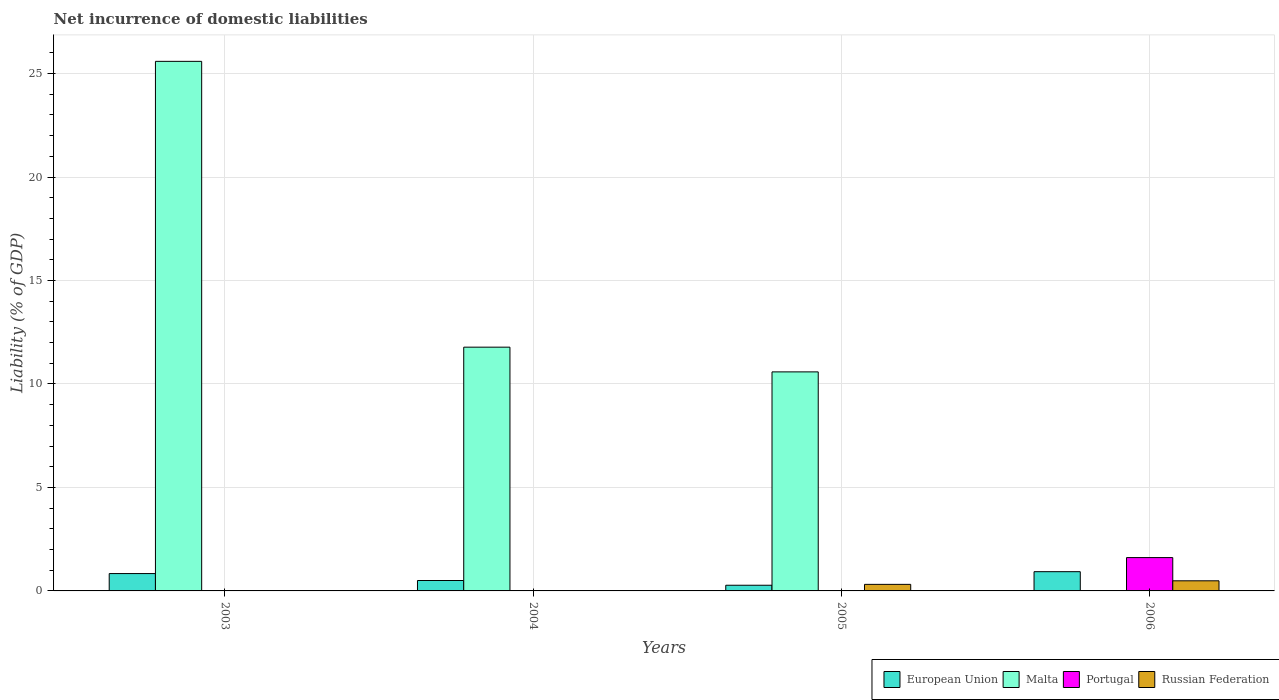How many groups of bars are there?
Offer a very short reply. 4. Are the number of bars on each tick of the X-axis equal?
Your answer should be very brief. No. How many bars are there on the 1st tick from the left?
Offer a terse response. 3. How many bars are there on the 3rd tick from the right?
Offer a very short reply. 2. In how many cases, is the number of bars for a given year not equal to the number of legend labels?
Your response must be concise. 4. What is the net incurrence of domestic liabilities in Portugal in 2003?
Your answer should be very brief. 0.01. Across all years, what is the maximum net incurrence of domestic liabilities in Malta?
Provide a short and direct response. 25.59. What is the total net incurrence of domestic liabilities in Portugal in the graph?
Ensure brevity in your answer.  1.62. What is the difference between the net incurrence of domestic liabilities in European Union in 2004 and that in 2006?
Provide a succinct answer. -0.43. What is the difference between the net incurrence of domestic liabilities in Portugal in 2003 and the net incurrence of domestic liabilities in European Union in 2004?
Your response must be concise. -0.49. What is the average net incurrence of domestic liabilities in European Union per year?
Provide a short and direct response. 0.64. In the year 2003, what is the difference between the net incurrence of domestic liabilities in Malta and net incurrence of domestic liabilities in Portugal?
Provide a succinct answer. 25.58. In how many years, is the net incurrence of domestic liabilities in Portugal greater than 5 %?
Make the answer very short. 0. What is the ratio of the net incurrence of domestic liabilities in European Union in 2003 to that in 2004?
Your answer should be compact. 1.67. What is the difference between the highest and the second highest net incurrence of domestic liabilities in Malta?
Give a very brief answer. 13.81. What is the difference between the highest and the lowest net incurrence of domestic liabilities in Russian Federation?
Ensure brevity in your answer.  0.49. Is the sum of the net incurrence of domestic liabilities in European Union in 2005 and 2006 greater than the maximum net incurrence of domestic liabilities in Russian Federation across all years?
Keep it short and to the point. Yes. Is it the case that in every year, the sum of the net incurrence of domestic liabilities in Portugal and net incurrence of domestic liabilities in Malta is greater than the sum of net incurrence of domestic liabilities in European Union and net incurrence of domestic liabilities in Russian Federation?
Your answer should be very brief. Yes. Is it the case that in every year, the sum of the net incurrence of domestic liabilities in Portugal and net incurrence of domestic liabilities in Russian Federation is greater than the net incurrence of domestic liabilities in Malta?
Offer a terse response. No. Are all the bars in the graph horizontal?
Give a very brief answer. No. What is the difference between two consecutive major ticks on the Y-axis?
Provide a short and direct response. 5. Are the values on the major ticks of Y-axis written in scientific E-notation?
Keep it short and to the point. No. Does the graph contain any zero values?
Offer a very short reply. Yes. How are the legend labels stacked?
Provide a short and direct response. Horizontal. What is the title of the graph?
Make the answer very short. Net incurrence of domestic liabilities. Does "Niger" appear as one of the legend labels in the graph?
Ensure brevity in your answer.  No. What is the label or title of the Y-axis?
Offer a very short reply. Liability (% of GDP). What is the Liability (% of GDP) in European Union in 2003?
Give a very brief answer. 0.84. What is the Liability (% of GDP) in Malta in 2003?
Offer a terse response. 25.59. What is the Liability (% of GDP) in Portugal in 2003?
Keep it short and to the point. 0.01. What is the Liability (% of GDP) of Russian Federation in 2003?
Your answer should be compact. 0. What is the Liability (% of GDP) of European Union in 2004?
Provide a short and direct response. 0.5. What is the Liability (% of GDP) of Malta in 2004?
Offer a very short reply. 11.78. What is the Liability (% of GDP) in European Union in 2005?
Your response must be concise. 0.27. What is the Liability (% of GDP) of Malta in 2005?
Your response must be concise. 10.58. What is the Liability (% of GDP) in Portugal in 2005?
Offer a terse response. 0. What is the Liability (% of GDP) of Russian Federation in 2005?
Offer a terse response. 0.32. What is the Liability (% of GDP) in European Union in 2006?
Offer a terse response. 0.93. What is the Liability (% of GDP) of Portugal in 2006?
Offer a very short reply. 1.61. What is the Liability (% of GDP) in Russian Federation in 2006?
Your answer should be compact. 0.49. Across all years, what is the maximum Liability (% of GDP) of European Union?
Give a very brief answer. 0.93. Across all years, what is the maximum Liability (% of GDP) in Malta?
Your response must be concise. 25.59. Across all years, what is the maximum Liability (% of GDP) of Portugal?
Make the answer very short. 1.61. Across all years, what is the maximum Liability (% of GDP) in Russian Federation?
Keep it short and to the point. 0.49. Across all years, what is the minimum Liability (% of GDP) of European Union?
Provide a succinct answer. 0.27. What is the total Liability (% of GDP) of European Union in the graph?
Your answer should be compact. 2.55. What is the total Liability (% of GDP) of Malta in the graph?
Your response must be concise. 47.95. What is the total Liability (% of GDP) in Portugal in the graph?
Ensure brevity in your answer.  1.62. What is the total Liability (% of GDP) in Russian Federation in the graph?
Offer a terse response. 0.81. What is the difference between the Liability (% of GDP) of European Union in 2003 and that in 2004?
Ensure brevity in your answer.  0.34. What is the difference between the Liability (% of GDP) of Malta in 2003 and that in 2004?
Ensure brevity in your answer.  13.81. What is the difference between the Liability (% of GDP) in European Union in 2003 and that in 2005?
Provide a succinct answer. 0.56. What is the difference between the Liability (% of GDP) of Malta in 2003 and that in 2005?
Provide a succinct answer. 15.01. What is the difference between the Liability (% of GDP) of European Union in 2003 and that in 2006?
Provide a succinct answer. -0.09. What is the difference between the Liability (% of GDP) in Portugal in 2003 and that in 2006?
Provide a short and direct response. -1.6. What is the difference between the Liability (% of GDP) in European Union in 2004 and that in 2005?
Keep it short and to the point. 0.23. What is the difference between the Liability (% of GDP) of Malta in 2004 and that in 2005?
Keep it short and to the point. 1.19. What is the difference between the Liability (% of GDP) in European Union in 2004 and that in 2006?
Provide a succinct answer. -0.43. What is the difference between the Liability (% of GDP) of European Union in 2005 and that in 2006?
Your response must be concise. -0.66. What is the difference between the Liability (% of GDP) in Russian Federation in 2005 and that in 2006?
Your answer should be compact. -0.17. What is the difference between the Liability (% of GDP) in European Union in 2003 and the Liability (% of GDP) in Malta in 2004?
Provide a short and direct response. -10.94. What is the difference between the Liability (% of GDP) of European Union in 2003 and the Liability (% of GDP) of Malta in 2005?
Offer a very short reply. -9.75. What is the difference between the Liability (% of GDP) in European Union in 2003 and the Liability (% of GDP) in Russian Federation in 2005?
Your answer should be very brief. 0.52. What is the difference between the Liability (% of GDP) of Malta in 2003 and the Liability (% of GDP) of Russian Federation in 2005?
Provide a succinct answer. 25.27. What is the difference between the Liability (% of GDP) in Portugal in 2003 and the Liability (% of GDP) in Russian Federation in 2005?
Your answer should be compact. -0.31. What is the difference between the Liability (% of GDP) of European Union in 2003 and the Liability (% of GDP) of Portugal in 2006?
Make the answer very short. -0.77. What is the difference between the Liability (% of GDP) in European Union in 2003 and the Liability (% of GDP) in Russian Federation in 2006?
Give a very brief answer. 0.35. What is the difference between the Liability (% of GDP) of Malta in 2003 and the Liability (% of GDP) of Portugal in 2006?
Provide a short and direct response. 23.98. What is the difference between the Liability (% of GDP) of Malta in 2003 and the Liability (% of GDP) of Russian Federation in 2006?
Your response must be concise. 25.1. What is the difference between the Liability (% of GDP) of Portugal in 2003 and the Liability (% of GDP) of Russian Federation in 2006?
Give a very brief answer. -0.48. What is the difference between the Liability (% of GDP) of European Union in 2004 and the Liability (% of GDP) of Malta in 2005?
Provide a succinct answer. -10.08. What is the difference between the Liability (% of GDP) in European Union in 2004 and the Liability (% of GDP) in Russian Federation in 2005?
Give a very brief answer. 0.19. What is the difference between the Liability (% of GDP) of Malta in 2004 and the Liability (% of GDP) of Russian Federation in 2005?
Ensure brevity in your answer.  11.46. What is the difference between the Liability (% of GDP) of European Union in 2004 and the Liability (% of GDP) of Portugal in 2006?
Give a very brief answer. -1.11. What is the difference between the Liability (% of GDP) in European Union in 2004 and the Liability (% of GDP) in Russian Federation in 2006?
Offer a terse response. 0.01. What is the difference between the Liability (% of GDP) in Malta in 2004 and the Liability (% of GDP) in Portugal in 2006?
Keep it short and to the point. 10.17. What is the difference between the Liability (% of GDP) in Malta in 2004 and the Liability (% of GDP) in Russian Federation in 2006?
Keep it short and to the point. 11.29. What is the difference between the Liability (% of GDP) of European Union in 2005 and the Liability (% of GDP) of Portugal in 2006?
Your answer should be very brief. -1.34. What is the difference between the Liability (% of GDP) of European Union in 2005 and the Liability (% of GDP) of Russian Federation in 2006?
Your response must be concise. -0.21. What is the difference between the Liability (% of GDP) in Malta in 2005 and the Liability (% of GDP) in Portugal in 2006?
Provide a succinct answer. 8.97. What is the difference between the Liability (% of GDP) of Malta in 2005 and the Liability (% of GDP) of Russian Federation in 2006?
Offer a terse response. 10.1. What is the average Liability (% of GDP) in European Union per year?
Provide a short and direct response. 0.64. What is the average Liability (% of GDP) of Malta per year?
Keep it short and to the point. 11.99. What is the average Liability (% of GDP) of Portugal per year?
Your response must be concise. 0.41. What is the average Liability (% of GDP) in Russian Federation per year?
Keep it short and to the point. 0.2. In the year 2003, what is the difference between the Liability (% of GDP) of European Union and Liability (% of GDP) of Malta?
Give a very brief answer. -24.75. In the year 2003, what is the difference between the Liability (% of GDP) of European Union and Liability (% of GDP) of Portugal?
Offer a very short reply. 0.83. In the year 2003, what is the difference between the Liability (% of GDP) in Malta and Liability (% of GDP) in Portugal?
Offer a terse response. 25.58. In the year 2004, what is the difference between the Liability (% of GDP) in European Union and Liability (% of GDP) in Malta?
Give a very brief answer. -11.28. In the year 2005, what is the difference between the Liability (% of GDP) in European Union and Liability (% of GDP) in Malta?
Your answer should be very brief. -10.31. In the year 2005, what is the difference between the Liability (% of GDP) of European Union and Liability (% of GDP) of Russian Federation?
Your answer should be compact. -0.04. In the year 2005, what is the difference between the Liability (% of GDP) in Malta and Liability (% of GDP) in Russian Federation?
Provide a short and direct response. 10.27. In the year 2006, what is the difference between the Liability (% of GDP) of European Union and Liability (% of GDP) of Portugal?
Provide a succinct answer. -0.68. In the year 2006, what is the difference between the Liability (% of GDP) in European Union and Liability (% of GDP) in Russian Federation?
Provide a succinct answer. 0.44. In the year 2006, what is the difference between the Liability (% of GDP) of Portugal and Liability (% of GDP) of Russian Federation?
Offer a very short reply. 1.12. What is the ratio of the Liability (% of GDP) in European Union in 2003 to that in 2004?
Your answer should be compact. 1.67. What is the ratio of the Liability (% of GDP) in Malta in 2003 to that in 2004?
Your answer should be very brief. 2.17. What is the ratio of the Liability (% of GDP) of European Union in 2003 to that in 2005?
Keep it short and to the point. 3.06. What is the ratio of the Liability (% of GDP) in Malta in 2003 to that in 2005?
Keep it short and to the point. 2.42. What is the ratio of the Liability (% of GDP) in European Union in 2003 to that in 2006?
Offer a terse response. 0.9. What is the ratio of the Liability (% of GDP) of Portugal in 2003 to that in 2006?
Make the answer very short. 0.01. What is the ratio of the Liability (% of GDP) in European Union in 2004 to that in 2005?
Offer a very short reply. 1.83. What is the ratio of the Liability (% of GDP) in Malta in 2004 to that in 2005?
Provide a succinct answer. 1.11. What is the ratio of the Liability (% of GDP) of European Union in 2004 to that in 2006?
Provide a short and direct response. 0.54. What is the ratio of the Liability (% of GDP) of European Union in 2005 to that in 2006?
Keep it short and to the point. 0.3. What is the ratio of the Liability (% of GDP) in Russian Federation in 2005 to that in 2006?
Give a very brief answer. 0.65. What is the difference between the highest and the second highest Liability (% of GDP) in European Union?
Keep it short and to the point. 0.09. What is the difference between the highest and the second highest Liability (% of GDP) in Malta?
Make the answer very short. 13.81. What is the difference between the highest and the lowest Liability (% of GDP) in European Union?
Provide a succinct answer. 0.66. What is the difference between the highest and the lowest Liability (% of GDP) of Malta?
Ensure brevity in your answer.  25.59. What is the difference between the highest and the lowest Liability (% of GDP) of Portugal?
Make the answer very short. 1.61. What is the difference between the highest and the lowest Liability (% of GDP) in Russian Federation?
Offer a very short reply. 0.49. 